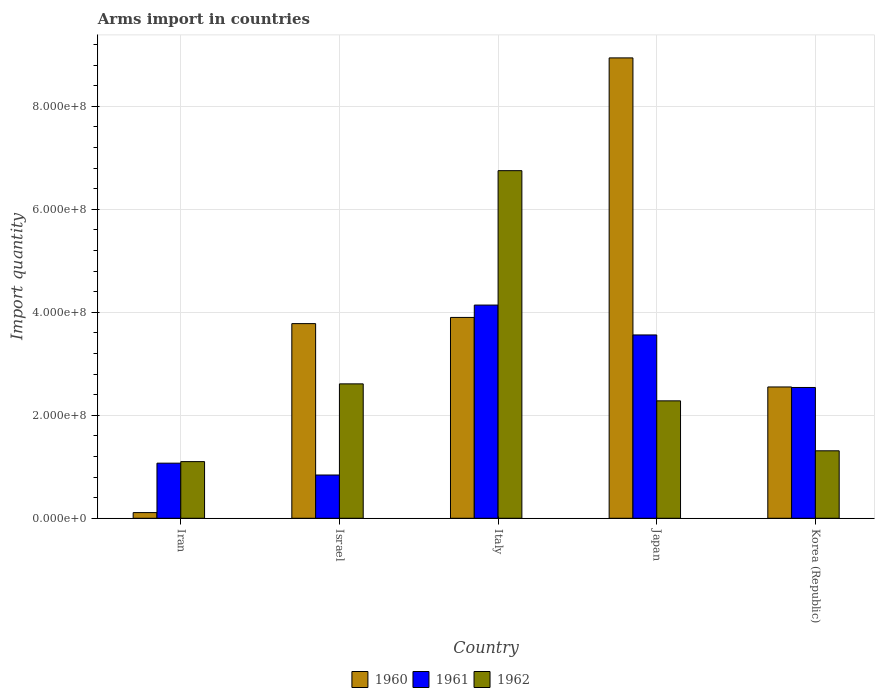How many different coloured bars are there?
Provide a short and direct response. 3. How many groups of bars are there?
Provide a short and direct response. 5. Are the number of bars on each tick of the X-axis equal?
Your response must be concise. Yes. How many bars are there on the 3rd tick from the right?
Provide a short and direct response. 3. What is the label of the 2nd group of bars from the left?
Keep it short and to the point. Israel. What is the total arms import in 1962 in Italy?
Your answer should be very brief. 6.75e+08. Across all countries, what is the maximum total arms import in 1962?
Provide a short and direct response. 6.75e+08. Across all countries, what is the minimum total arms import in 1961?
Provide a short and direct response. 8.40e+07. In which country was the total arms import in 1960 maximum?
Give a very brief answer. Japan. In which country was the total arms import in 1961 minimum?
Provide a succinct answer. Israel. What is the total total arms import in 1962 in the graph?
Give a very brief answer. 1.40e+09. What is the difference between the total arms import in 1960 in Iran and that in Korea (Republic)?
Provide a short and direct response. -2.44e+08. What is the difference between the total arms import in 1961 in Italy and the total arms import in 1960 in Iran?
Keep it short and to the point. 4.03e+08. What is the average total arms import in 1962 per country?
Your response must be concise. 2.81e+08. What is the difference between the total arms import of/in 1960 and total arms import of/in 1962 in Israel?
Your answer should be compact. 1.17e+08. In how many countries, is the total arms import in 1960 greater than 840000000?
Offer a terse response. 1. What is the ratio of the total arms import in 1962 in Italy to that in Japan?
Provide a short and direct response. 2.96. Is the total arms import in 1962 in Italy less than that in Korea (Republic)?
Give a very brief answer. No. What is the difference between the highest and the second highest total arms import in 1960?
Offer a terse response. 5.04e+08. What is the difference between the highest and the lowest total arms import in 1962?
Offer a very short reply. 5.65e+08. In how many countries, is the total arms import in 1960 greater than the average total arms import in 1960 taken over all countries?
Your response must be concise. 2. What does the 3rd bar from the right in Iran represents?
Your answer should be very brief. 1960. Is it the case that in every country, the sum of the total arms import in 1960 and total arms import in 1961 is greater than the total arms import in 1962?
Your answer should be very brief. Yes. How many countries are there in the graph?
Your answer should be very brief. 5. Does the graph contain any zero values?
Offer a terse response. No. How many legend labels are there?
Offer a terse response. 3. How are the legend labels stacked?
Your response must be concise. Horizontal. What is the title of the graph?
Provide a succinct answer. Arms import in countries. What is the label or title of the Y-axis?
Give a very brief answer. Import quantity. What is the Import quantity in 1960 in Iran?
Ensure brevity in your answer.  1.10e+07. What is the Import quantity of 1961 in Iran?
Offer a very short reply. 1.07e+08. What is the Import quantity in 1962 in Iran?
Your answer should be very brief. 1.10e+08. What is the Import quantity of 1960 in Israel?
Make the answer very short. 3.78e+08. What is the Import quantity of 1961 in Israel?
Provide a short and direct response. 8.40e+07. What is the Import quantity in 1962 in Israel?
Keep it short and to the point. 2.61e+08. What is the Import quantity in 1960 in Italy?
Your response must be concise. 3.90e+08. What is the Import quantity in 1961 in Italy?
Offer a terse response. 4.14e+08. What is the Import quantity of 1962 in Italy?
Offer a very short reply. 6.75e+08. What is the Import quantity of 1960 in Japan?
Your response must be concise. 8.94e+08. What is the Import quantity in 1961 in Japan?
Your answer should be compact. 3.56e+08. What is the Import quantity of 1962 in Japan?
Offer a very short reply. 2.28e+08. What is the Import quantity in 1960 in Korea (Republic)?
Give a very brief answer. 2.55e+08. What is the Import quantity of 1961 in Korea (Republic)?
Your answer should be compact. 2.54e+08. What is the Import quantity in 1962 in Korea (Republic)?
Offer a terse response. 1.31e+08. Across all countries, what is the maximum Import quantity of 1960?
Your answer should be very brief. 8.94e+08. Across all countries, what is the maximum Import quantity of 1961?
Keep it short and to the point. 4.14e+08. Across all countries, what is the maximum Import quantity in 1962?
Provide a succinct answer. 6.75e+08. Across all countries, what is the minimum Import quantity in 1960?
Keep it short and to the point. 1.10e+07. Across all countries, what is the minimum Import quantity of 1961?
Ensure brevity in your answer.  8.40e+07. Across all countries, what is the minimum Import quantity in 1962?
Your response must be concise. 1.10e+08. What is the total Import quantity of 1960 in the graph?
Your answer should be compact. 1.93e+09. What is the total Import quantity in 1961 in the graph?
Ensure brevity in your answer.  1.22e+09. What is the total Import quantity of 1962 in the graph?
Your answer should be compact. 1.40e+09. What is the difference between the Import quantity in 1960 in Iran and that in Israel?
Give a very brief answer. -3.67e+08. What is the difference between the Import quantity in 1961 in Iran and that in Israel?
Provide a succinct answer. 2.30e+07. What is the difference between the Import quantity of 1962 in Iran and that in Israel?
Offer a terse response. -1.51e+08. What is the difference between the Import quantity of 1960 in Iran and that in Italy?
Make the answer very short. -3.79e+08. What is the difference between the Import quantity in 1961 in Iran and that in Italy?
Your answer should be very brief. -3.07e+08. What is the difference between the Import quantity in 1962 in Iran and that in Italy?
Offer a very short reply. -5.65e+08. What is the difference between the Import quantity in 1960 in Iran and that in Japan?
Provide a succinct answer. -8.83e+08. What is the difference between the Import quantity of 1961 in Iran and that in Japan?
Provide a short and direct response. -2.49e+08. What is the difference between the Import quantity in 1962 in Iran and that in Japan?
Make the answer very short. -1.18e+08. What is the difference between the Import quantity of 1960 in Iran and that in Korea (Republic)?
Offer a very short reply. -2.44e+08. What is the difference between the Import quantity in 1961 in Iran and that in Korea (Republic)?
Provide a short and direct response. -1.47e+08. What is the difference between the Import quantity in 1962 in Iran and that in Korea (Republic)?
Give a very brief answer. -2.10e+07. What is the difference between the Import quantity of 1960 in Israel and that in Italy?
Make the answer very short. -1.20e+07. What is the difference between the Import quantity in 1961 in Israel and that in Italy?
Provide a short and direct response. -3.30e+08. What is the difference between the Import quantity of 1962 in Israel and that in Italy?
Keep it short and to the point. -4.14e+08. What is the difference between the Import quantity of 1960 in Israel and that in Japan?
Ensure brevity in your answer.  -5.16e+08. What is the difference between the Import quantity in 1961 in Israel and that in Japan?
Give a very brief answer. -2.72e+08. What is the difference between the Import quantity in 1962 in Israel and that in Japan?
Provide a short and direct response. 3.30e+07. What is the difference between the Import quantity of 1960 in Israel and that in Korea (Republic)?
Your answer should be compact. 1.23e+08. What is the difference between the Import quantity of 1961 in Israel and that in Korea (Republic)?
Offer a very short reply. -1.70e+08. What is the difference between the Import quantity of 1962 in Israel and that in Korea (Republic)?
Your response must be concise. 1.30e+08. What is the difference between the Import quantity in 1960 in Italy and that in Japan?
Your answer should be very brief. -5.04e+08. What is the difference between the Import quantity in 1961 in Italy and that in Japan?
Your answer should be compact. 5.80e+07. What is the difference between the Import quantity of 1962 in Italy and that in Japan?
Offer a terse response. 4.47e+08. What is the difference between the Import quantity of 1960 in Italy and that in Korea (Republic)?
Your response must be concise. 1.35e+08. What is the difference between the Import quantity of 1961 in Italy and that in Korea (Republic)?
Provide a short and direct response. 1.60e+08. What is the difference between the Import quantity of 1962 in Italy and that in Korea (Republic)?
Provide a short and direct response. 5.44e+08. What is the difference between the Import quantity of 1960 in Japan and that in Korea (Republic)?
Provide a short and direct response. 6.39e+08. What is the difference between the Import quantity in 1961 in Japan and that in Korea (Republic)?
Offer a very short reply. 1.02e+08. What is the difference between the Import quantity of 1962 in Japan and that in Korea (Republic)?
Ensure brevity in your answer.  9.70e+07. What is the difference between the Import quantity of 1960 in Iran and the Import quantity of 1961 in Israel?
Provide a succinct answer. -7.30e+07. What is the difference between the Import quantity of 1960 in Iran and the Import quantity of 1962 in Israel?
Keep it short and to the point. -2.50e+08. What is the difference between the Import quantity of 1961 in Iran and the Import quantity of 1962 in Israel?
Your answer should be compact. -1.54e+08. What is the difference between the Import quantity in 1960 in Iran and the Import quantity in 1961 in Italy?
Your answer should be very brief. -4.03e+08. What is the difference between the Import quantity in 1960 in Iran and the Import quantity in 1962 in Italy?
Keep it short and to the point. -6.64e+08. What is the difference between the Import quantity in 1961 in Iran and the Import quantity in 1962 in Italy?
Your response must be concise. -5.68e+08. What is the difference between the Import quantity in 1960 in Iran and the Import quantity in 1961 in Japan?
Ensure brevity in your answer.  -3.45e+08. What is the difference between the Import quantity of 1960 in Iran and the Import quantity of 1962 in Japan?
Give a very brief answer. -2.17e+08. What is the difference between the Import quantity of 1961 in Iran and the Import quantity of 1962 in Japan?
Give a very brief answer. -1.21e+08. What is the difference between the Import quantity of 1960 in Iran and the Import quantity of 1961 in Korea (Republic)?
Provide a short and direct response. -2.43e+08. What is the difference between the Import quantity of 1960 in Iran and the Import quantity of 1962 in Korea (Republic)?
Your response must be concise. -1.20e+08. What is the difference between the Import quantity in 1961 in Iran and the Import quantity in 1962 in Korea (Republic)?
Keep it short and to the point. -2.40e+07. What is the difference between the Import quantity of 1960 in Israel and the Import quantity of 1961 in Italy?
Provide a succinct answer. -3.60e+07. What is the difference between the Import quantity of 1960 in Israel and the Import quantity of 1962 in Italy?
Offer a very short reply. -2.97e+08. What is the difference between the Import quantity of 1961 in Israel and the Import quantity of 1962 in Italy?
Offer a terse response. -5.91e+08. What is the difference between the Import quantity in 1960 in Israel and the Import quantity in 1961 in Japan?
Your answer should be very brief. 2.20e+07. What is the difference between the Import quantity of 1960 in Israel and the Import quantity of 1962 in Japan?
Your answer should be compact. 1.50e+08. What is the difference between the Import quantity in 1961 in Israel and the Import quantity in 1962 in Japan?
Make the answer very short. -1.44e+08. What is the difference between the Import quantity of 1960 in Israel and the Import quantity of 1961 in Korea (Republic)?
Give a very brief answer. 1.24e+08. What is the difference between the Import quantity in 1960 in Israel and the Import quantity in 1962 in Korea (Republic)?
Give a very brief answer. 2.47e+08. What is the difference between the Import quantity in 1961 in Israel and the Import quantity in 1962 in Korea (Republic)?
Offer a very short reply. -4.70e+07. What is the difference between the Import quantity of 1960 in Italy and the Import quantity of 1961 in Japan?
Your answer should be compact. 3.40e+07. What is the difference between the Import quantity of 1960 in Italy and the Import quantity of 1962 in Japan?
Offer a very short reply. 1.62e+08. What is the difference between the Import quantity in 1961 in Italy and the Import quantity in 1962 in Japan?
Make the answer very short. 1.86e+08. What is the difference between the Import quantity of 1960 in Italy and the Import quantity of 1961 in Korea (Republic)?
Ensure brevity in your answer.  1.36e+08. What is the difference between the Import quantity in 1960 in Italy and the Import quantity in 1962 in Korea (Republic)?
Your response must be concise. 2.59e+08. What is the difference between the Import quantity in 1961 in Italy and the Import quantity in 1962 in Korea (Republic)?
Offer a terse response. 2.83e+08. What is the difference between the Import quantity of 1960 in Japan and the Import quantity of 1961 in Korea (Republic)?
Make the answer very short. 6.40e+08. What is the difference between the Import quantity of 1960 in Japan and the Import quantity of 1962 in Korea (Republic)?
Give a very brief answer. 7.63e+08. What is the difference between the Import quantity of 1961 in Japan and the Import quantity of 1962 in Korea (Republic)?
Offer a very short reply. 2.25e+08. What is the average Import quantity of 1960 per country?
Provide a short and direct response. 3.86e+08. What is the average Import quantity of 1961 per country?
Keep it short and to the point. 2.43e+08. What is the average Import quantity in 1962 per country?
Keep it short and to the point. 2.81e+08. What is the difference between the Import quantity in 1960 and Import quantity in 1961 in Iran?
Provide a short and direct response. -9.60e+07. What is the difference between the Import quantity of 1960 and Import quantity of 1962 in Iran?
Give a very brief answer. -9.90e+07. What is the difference between the Import quantity in 1961 and Import quantity in 1962 in Iran?
Ensure brevity in your answer.  -3.00e+06. What is the difference between the Import quantity in 1960 and Import quantity in 1961 in Israel?
Ensure brevity in your answer.  2.94e+08. What is the difference between the Import quantity of 1960 and Import quantity of 1962 in Israel?
Offer a terse response. 1.17e+08. What is the difference between the Import quantity in 1961 and Import quantity in 1962 in Israel?
Make the answer very short. -1.77e+08. What is the difference between the Import quantity in 1960 and Import quantity in 1961 in Italy?
Give a very brief answer. -2.40e+07. What is the difference between the Import quantity in 1960 and Import quantity in 1962 in Italy?
Give a very brief answer. -2.85e+08. What is the difference between the Import quantity in 1961 and Import quantity in 1962 in Italy?
Your answer should be very brief. -2.61e+08. What is the difference between the Import quantity of 1960 and Import quantity of 1961 in Japan?
Offer a very short reply. 5.38e+08. What is the difference between the Import quantity in 1960 and Import quantity in 1962 in Japan?
Offer a very short reply. 6.66e+08. What is the difference between the Import quantity of 1961 and Import quantity of 1962 in Japan?
Provide a succinct answer. 1.28e+08. What is the difference between the Import quantity in 1960 and Import quantity in 1961 in Korea (Republic)?
Ensure brevity in your answer.  1.00e+06. What is the difference between the Import quantity in 1960 and Import quantity in 1962 in Korea (Republic)?
Offer a terse response. 1.24e+08. What is the difference between the Import quantity of 1961 and Import quantity of 1962 in Korea (Republic)?
Offer a terse response. 1.23e+08. What is the ratio of the Import quantity in 1960 in Iran to that in Israel?
Give a very brief answer. 0.03. What is the ratio of the Import quantity of 1961 in Iran to that in Israel?
Ensure brevity in your answer.  1.27. What is the ratio of the Import quantity of 1962 in Iran to that in Israel?
Ensure brevity in your answer.  0.42. What is the ratio of the Import quantity of 1960 in Iran to that in Italy?
Your answer should be compact. 0.03. What is the ratio of the Import quantity of 1961 in Iran to that in Italy?
Give a very brief answer. 0.26. What is the ratio of the Import quantity in 1962 in Iran to that in Italy?
Your answer should be compact. 0.16. What is the ratio of the Import quantity in 1960 in Iran to that in Japan?
Provide a short and direct response. 0.01. What is the ratio of the Import quantity of 1961 in Iran to that in Japan?
Provide a succinct answer. 0.3. What is the ratio of the Import quantity in 1962 in Iran to that in Japan?
Offer a terse response. 0.48. What is the ratio of the Import quantity of 1960 in Iran to that in Korea (Republic)?
Provide a short and direct response. 0.04. What is the ratio of the Import quantity in 1961 in Iran to that in Korea (Republic)?
Keep it short and to the point. 0.42. What is the ratio of the Import quantity in 1962 in Iran to that in Korea (Republic)?
Provide a succinct answer. 0.84. What is the ratio of the Import quantity of 1960 in Israel to that in Italy?
Keep it short and to the point. 0.97. What is the ratio of the Import quantity in 1961 in Israel to that in Italy?
Offer a very short reply. 0.2. What is the ratio of the Import quantity in 1962 in Israel to that in Italy?
Your answer should be compact. 0.39. What is the ratio of the Import quantity in 1960 in Israel to that in Japan?
Offer a very short reply. 0.42. What is the ratio of the Import quantity of 1961 in Israel to that in Japan?
Offer a very short reply. 0.24. What is the ratio of the Import quantity in 1962 in Israel to that in Japan?
Make the answer very short. 1.14. What is the ratio of the Import quantity in 1960 in Israel to that in Korea (Republic)?
Offer a very short reply. 1.48. What is the ratio of the Import quantity in 1961 in Israel to that in Korea (Republic)?
Make the answer very short. 0.33. What is the ratio of the Import quantity of 1962 in Israel to that in Korea (Republic)?
Provide a short and direct response. 1.99. What is the ratio of the Import quantity of 1960 in Italy to that in Japan?
Provide a succinct answer. 0.44. What is the ratio of the Import quantity in 1961 in Italy to that in Japan?
Your answer should be very brief. 1.16. What is the ratio of the Import quantity of 1962 in Italy to that in Japan?
Ensure brevity in your answer.  2.96. What is the ratio of the Import quantity in 1960 in Italy to that in Korea (Republic)?
Keep it short and to the point. 1.53. What is the ratio of the Import quantity in 1961 in Italy to that in Korea (Republic)?
Ensure brevity in your answer.  1.63. What is the ratio of the Import quantity of 1962 in Italy to that in Korea (Republic)?
Keep it short and to the point. 5.15. What is the ratio of the Import quantity in 1960 in Japan to that in Korea (Republic)?
Make the answer very short. 3.51. What is the ratio of the Import quantity of 1961 in Japan to that in Korea (Republic)?
Make the answer very short. 1.4. What is the ratio of the Import quantity of 1962 in Japan to that in Korea (Republic)?
Keep it short and to the point. 1.74. What is the difference between the highest and the second highest Import quantity in 1960?
Offer a terse response. 5.04e+08. What is the difference between the highest and the second highest Import quantity in 1961?
Provide a short and direct response. 5.80e+07. What is the difference between the highest and the second highest Import quantity of 1962?
Offer a very short reply. 4.14e+08. What is the difference between the highest and the lowest Import quantity in 1960?
Keep it short and to the point. 8.83e+08. What is the difference between the highest and the lowest Import quantity in 1961?
Offer a very short reply. 3.30e+08. What is the difference between the highest and the lowest Import quantity of 1962?
Give a very brief answer. 5.65e+08. 